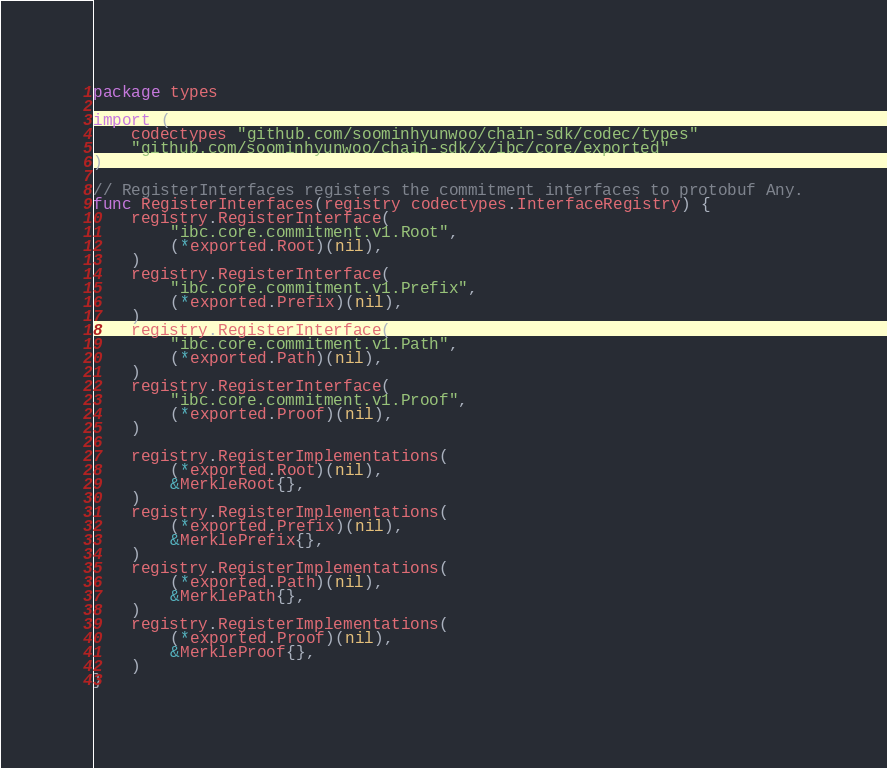<code> <loc_0><loc_0><loc_500><loc_500><_Go_>package types

import (
	codectypes "github.com/soominhyunwoo/chain-sdk/codec/types"
	"github.com/soominhyunwoo/chain-sdk/x/ibc/core/exported"
)

// RegisterInterfaces registers the commitment interfaces to protobuf Any.
func RegisterInterfaces(registry codectypes.InterfaceRegistry) {
	registry.RegisterInterface(
		"ibc.core.commitment.v1.Root",
		(*exported.Root)(nil),
	)
	registry.RegisterInterface(
		"ibc.core.commitment.v1.Prefix",
		(*exported.Prefix)(nil),
	)
	registry.RegisterInterface(
		"ibc.core.commitment.v1.Path",
		(*exported.Path)(nil),
	)
	registry.RegisterInterface(
		"ibc.core.commitment.v1.Proof",
		(*exported.Proof)(nil),
	)

	registry.RegisterImplementations(
		(*exported.Root)(nil),
		&MerkleRoot{},
	)
	registry.RegisterImplementations(
		(*exported.Prefix)(nil),
		&MerklePrefix{},
	)
	registry.RegisterImplementations(
		(*exported.Path)(nil),
		&MerklePath{},
	)
	registry.RegisterImplementations(
		(*exported.Proof)(nil),
		&MerkleProof{},
	)
}
</code> 